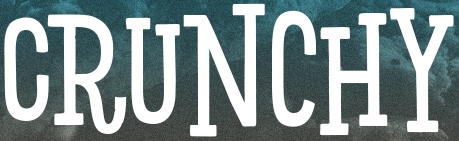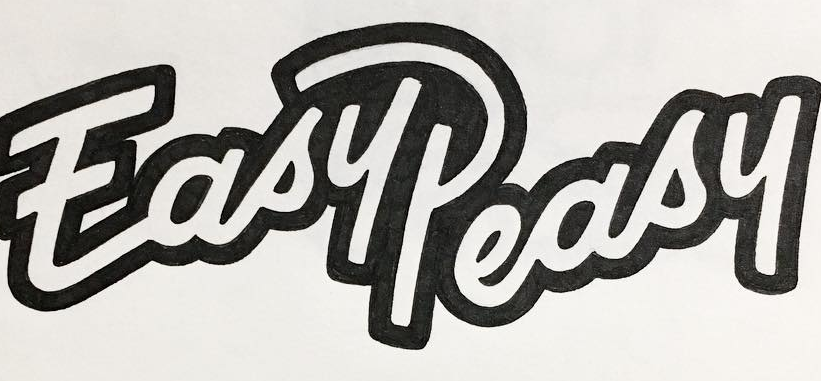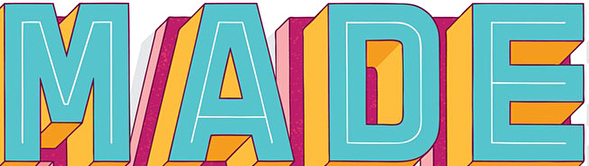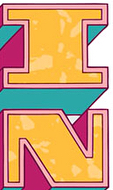Read the text from these images in sequence, separated by a semicolon. CRUNCHY; EasyPeasy; MADE; IN 